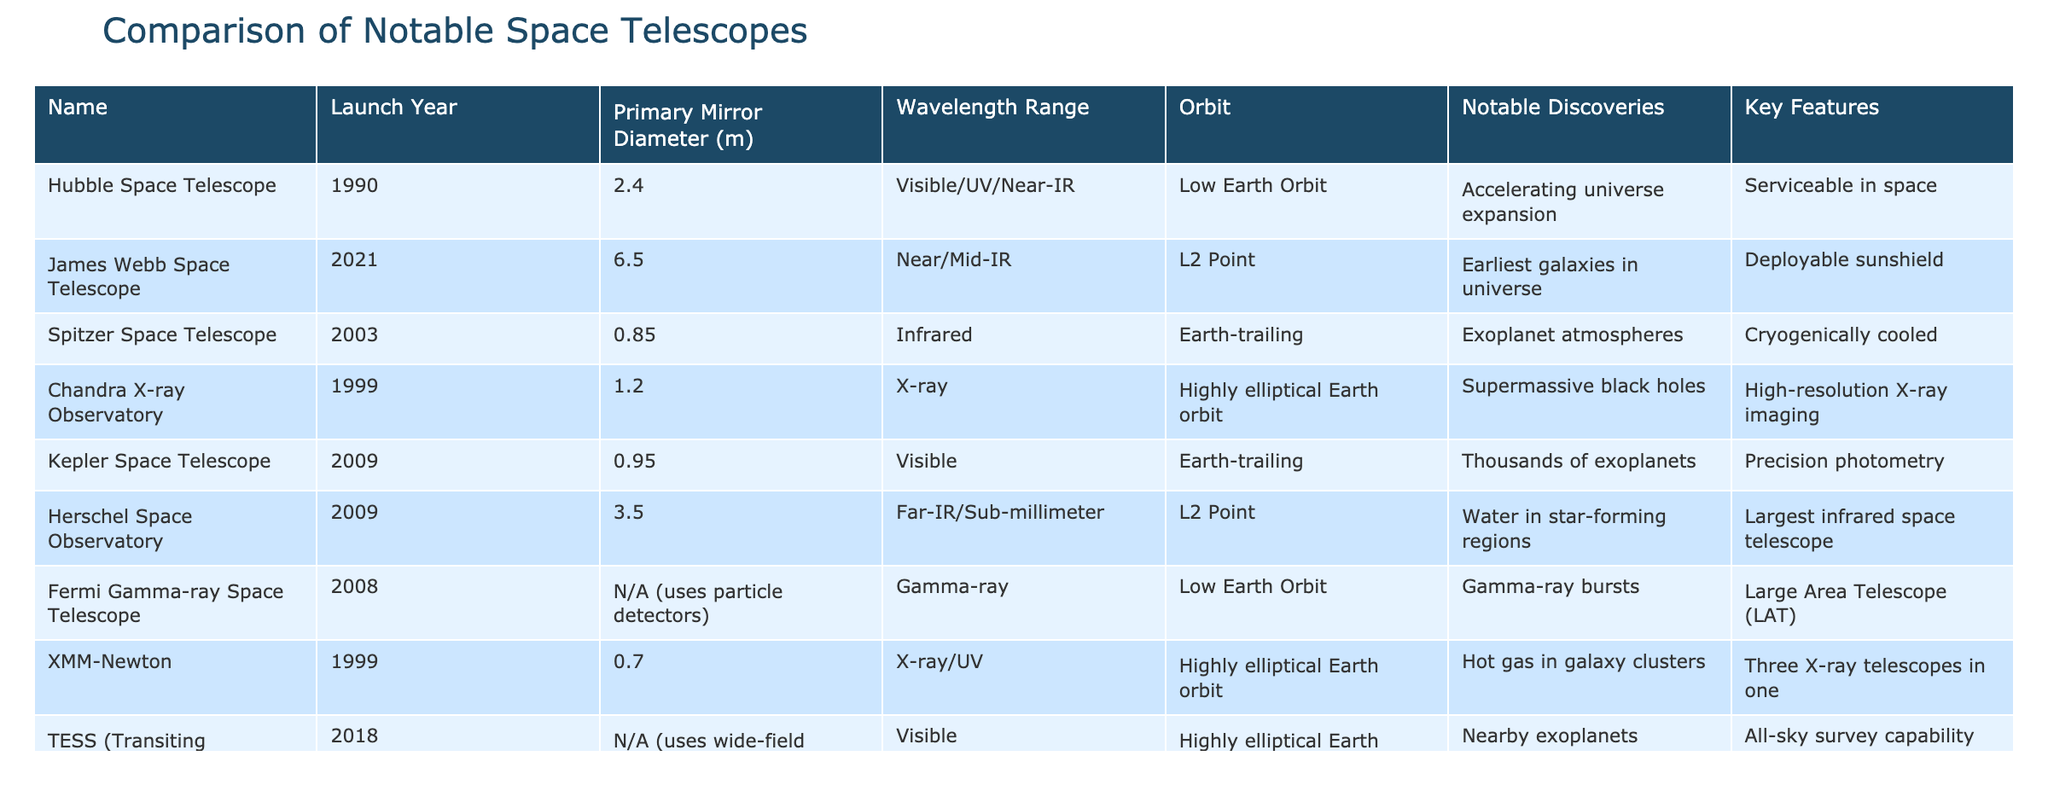What is the primary mirror diameter of the James Webb Space Telescope? The table indicates that the primary mirror diameter of the James Webb Space Telescope is 6.5 meters.
Answer: 6.5 m Which telescope operates at the L2 Point? The table shows that both the James Webb Space Telescope and the Herschel Space Observatory operate at the L2 Point.
Answer: James Webb Space Telescope and Herschel Space Observatory Is the Hubble Space Telescope capable of detecting X-rays? The table indicates that the Hubble Space Telescope operates in the visible, UV, and near-infrared range but does not mention X-ray capabilities. Therefore, it cannot detect X-rays.
Answer: No How many notable discoveries are listed for the Kepler Space Telescope? The table states that the Kepler Space Telescope has one notable discovery listed, which is "Thousands of exoplanets."
Answer: One What is the average primary mirror diameter of the telescopes that operate in the visible range? The visible range telescopes listed are Hubble Space Telescope (2.4 m) and Kepler Space Telescope (0.95 m). Summing these gives 3.35 m. Dividing by the number of telescopes (2), the average is 1.675 m.
Answer: 1.675 m Which telescope has the largest primary mirror diameter? Referring to the table, the James Webb Space Telescope has the largest primary mirror diameter at 6.5 meters compared to the others.
Answer: James Webb Space Telescope Does the Fermi Gamma-ray Space Telescope have a primary mirror diameter listed? The table shows that the Fermi Gamma-ray Space Telescope uses particle detectors and does not have a primary mirror diameter listed, indicating that it operates differently from reflective telescopes.
Answer: No How many telescopes listed are designed to study exoplanets? The table indicates that the Kepler Space Telescope and TESS are designed to study exoplanets. Thus, there are two telescopes doing so.
Answer: Two 